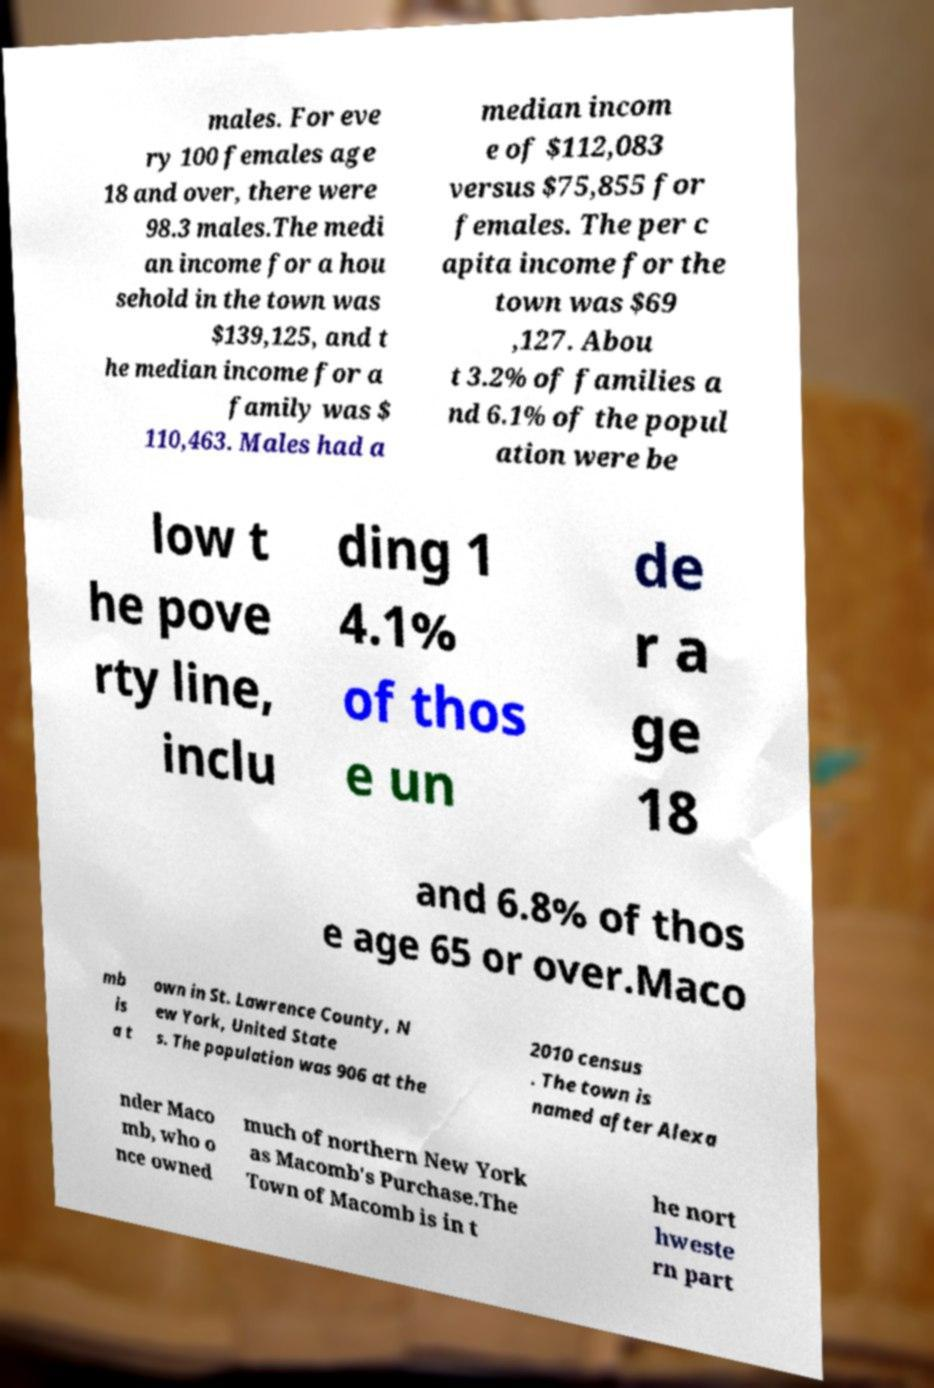Please read and relay the text visible in this image. What does it say? males. For eve ry 100 females age 18 and over, there were 98.3 males.The medi an income for a hou sehold in the town was $139,125, and t he median income for a family was $ 110,463. Males had a median incom e of $112,083 versus $75,855 for females. The per c apita income for the town was $69 ,127. Abou t 3.2% of families a nd 6.1% of the popul ation were be low t he pove rty line, inclu ding 1 4.1% of thos e un de r a ge 18 and 6.8% of thos e age 65 or over.Maco mb is a t own in St. Lawrence County, N ew York, United State s. The population was 906 at the 2010 census . The town is named after Alexa nder Maco mb, who o nce owned much of northern New York as Macomb's Purchase.The Town of Macomb is in t he nort hweste rn part 